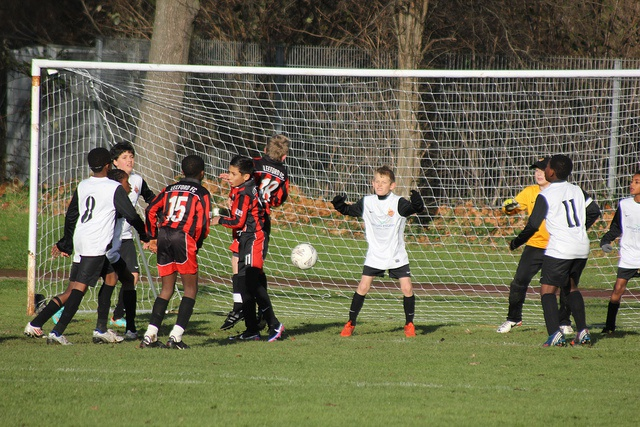Describe the objects in this image and their specific colors. I can see people in black, white, gray, and darkgreen tones, people in black, red, olive, and gray tones, people in black, white, gray, and olive tones, people in black, white, tan, and gray tones, and people in black, red, gray, and maroon tones in this image. 